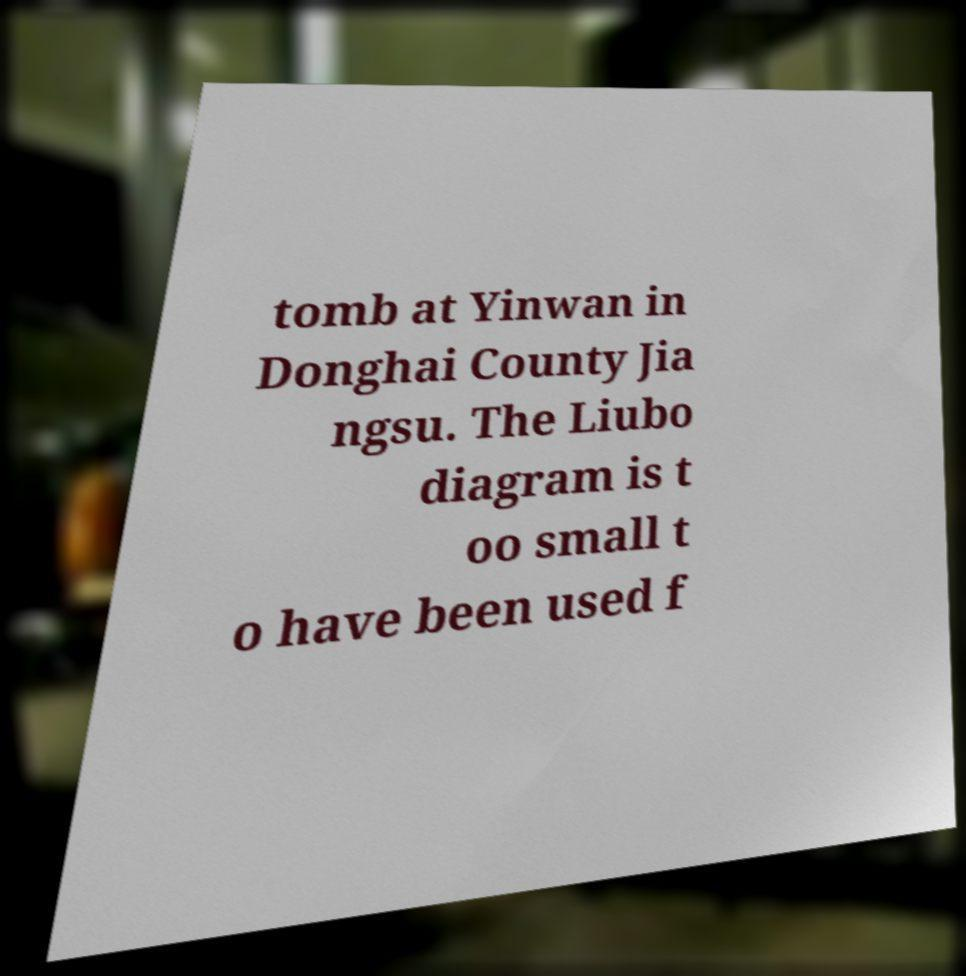Please identify and transcribe the text found in this image. tomb at Yinwan in Donghai County Jia ngsu. The Liubo diagram is t oo small t o have been used f 